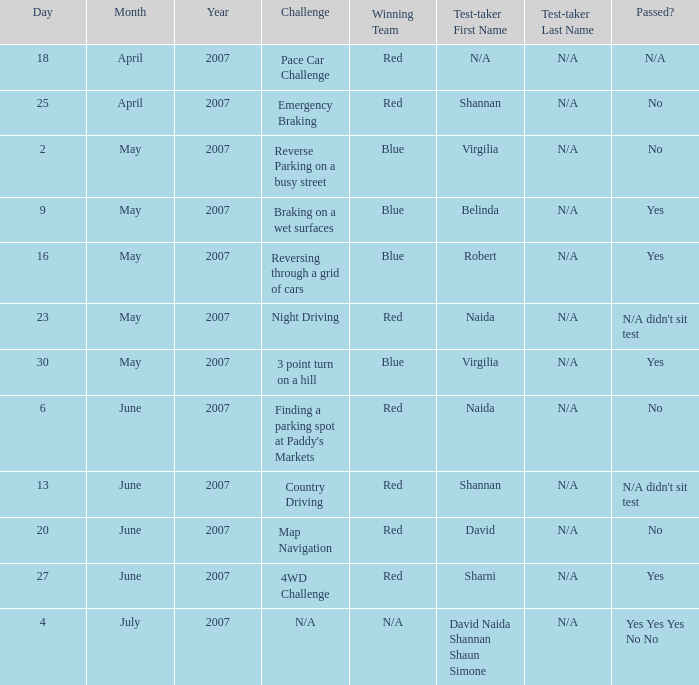What is the result for passing in the country driving challenge? N/A didn't sit test. 